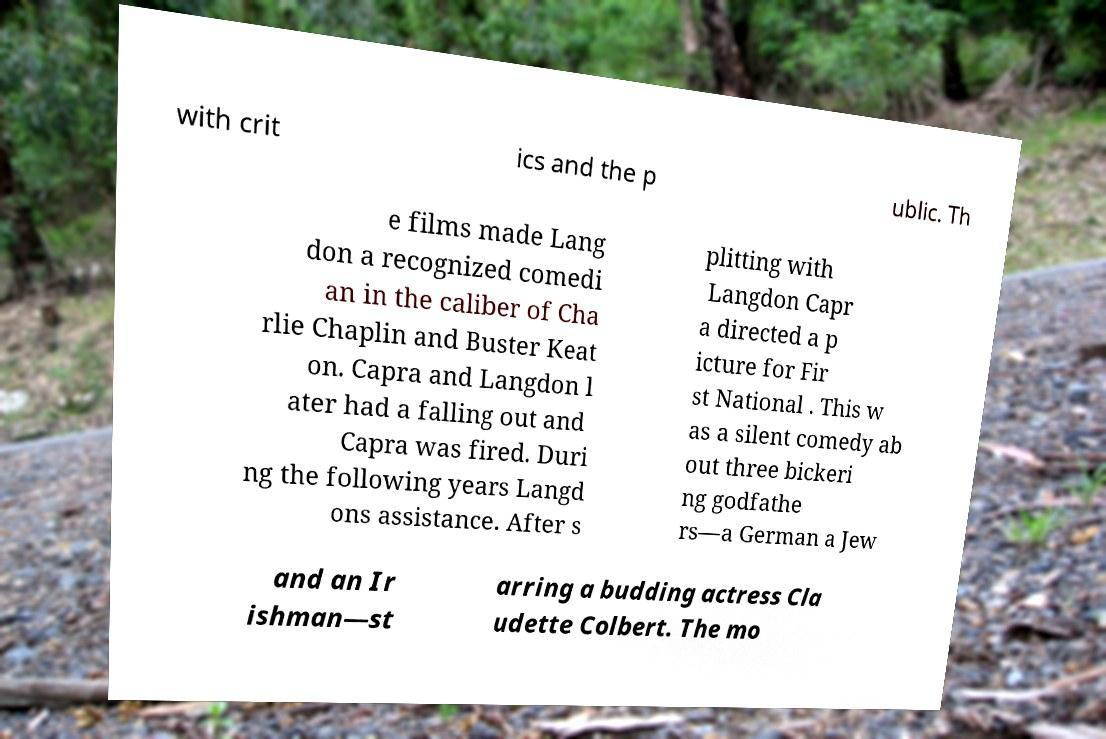Could you extract and type out the text from this image? with crit ics and the p ublic. Th e films made Lang don a recognized comedi an in the caliber of Cha rlie Chaplin and Buster Keat on. Capra and Langdon l ater had a falling out and Capra was fired. Duri ng the following years Langd ons assistance. After s plitting with Langdon Capr a directed a p icture for Fir st National . This w as a silent comedy ab out three bickeri ng godfathe rs—a German a Jew and an Ir ishman—st arring a budding actress Cla udette Colbert. The mo 